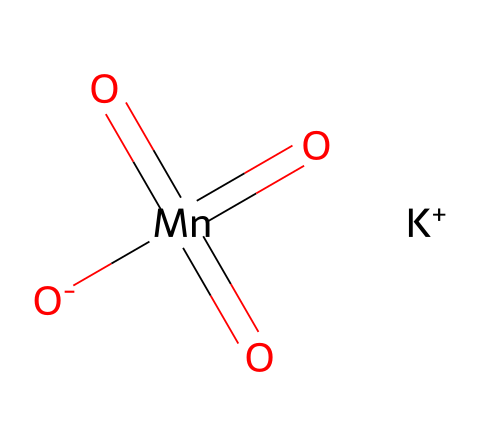What is the molecular formula of potassium permanganate? The molecular formula can be derived from the SMILES representation. It consists of 1 potassium (K), 1 manganese (Mn), and 4 oxygen (O) atoms, resulting in the formula KMnO4.
Answer: KMnO4 How many oxygen atoms are present in potassium permanganate? By analyzing the SMILES structure, we can count four oxygen atoms (indicated by the four 'O's) in the molecule.
Answer: 4 What charge does the potassium ion carry in this chemical? The SMILES notation shows [K+], indicating that potassium carries a +1 charge.
Answer: +1 What is the oxidation state of manganese in potassium permanganate? Manganese (Mn) in KMnO4 has a formal oxidation state of +7, which is inferred from its bonding context within this compound.
Answer: +7 How many total atoms are in the potassium permanganate molecule? The molecular formula KMnO4 consists of 6 atoms in total (1 K, 1 Mn, and 4 O), which can be summed up for a complete count.
Answer: 6 Which elements are present in potassium permanganate? From the SMILES representation, we can identify the elements: potassium (K), manganese (Mn), and oxygen (O).
Answer: potassium, manganese, oxygen What type of chemical compound is potassium permanganate? Based on its use as an oxidizing agent and the presence of a metal and oxygen in its structure, it is classified as an inorganic salt.
Answer: inorganic salt 